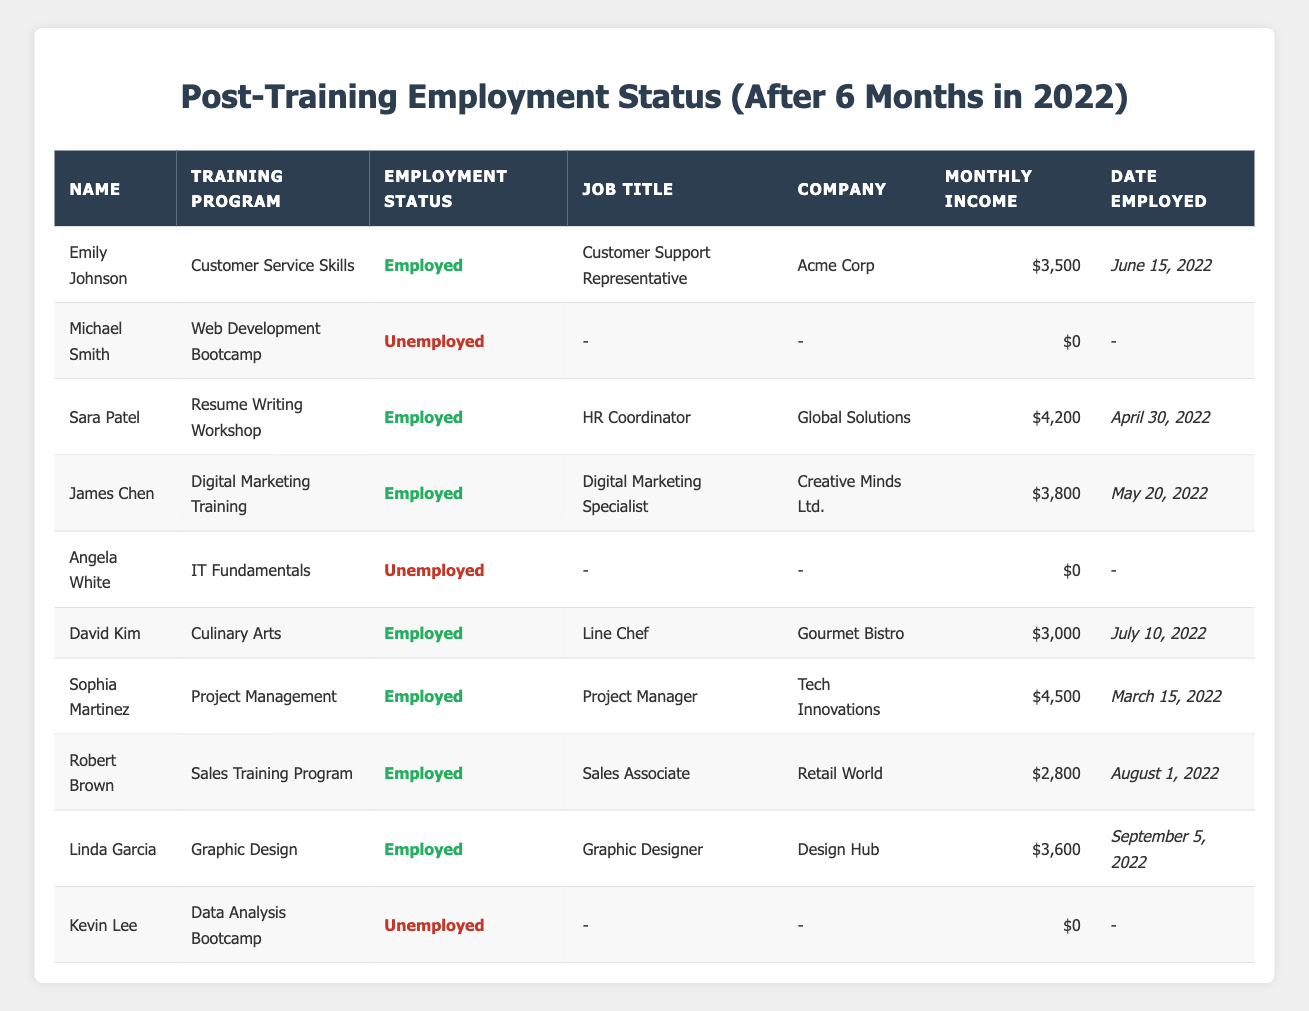What is the job title of Emily Johnson? According to the table, Emily Johnson holds the job title of "Customer Support Representative" under the "Employment Status" section.
Answer: Customer Support Representative How many participants are unemployed after the training? The table shows three entries (Michael Smith, Angela White, and Kevin Lee) with the "Employment Status" marked as "Unemployed." Thus, there are three unemployed participants.
Answer: 3 What is the total monthly income of all employed participants? Adding the monthly incomes of all employed participants: $3,500 (Emily) + $4,200 (Sara) + $3,800 (James) + $3,000 (David) + $4,500 (Sophia) + $2,800 (Robert) + $3,600 (Linda) = $25,400.
Answer: $25,400 Which training program had the highest earning participant? The participant with the highest monthly income is Sophia Martinez from the "Project Management" training program, earning $4,500 per month.
Answer: Project Management Is there more than one participant with the same job title? Checking the table, there are no duplicates in job titles: each participant has a unique title. Therefore, the answer is no.
Answer: No What was the average monthly income of employed participants? Calculating the average: Total income of employed participants is $25,400. There are 7 employed participants. Average = $25,400 / 7 = $3,628.57.
Answer: $3,628.57 Which participant had the earliest employment date? The earliest date in the "Date Employed" column is for Sophia Martinez, who was employed on "March 15, 2022."
Answer: Sophia Martinez How many participants were in training programs related to IT or technology fields? The relevant training programs are "Web Development Bootcamp," "IT Fundamentals," and "Data Analysis Bootcamp," which include Michael Smith, Angela White, and Kevin Lee. Thus, there are three participants.
Answer: 3 What is the difference in monthly income between the highest and lowest earning participants? The highest earning participant is Sophia Martinez with $4,500, and the lowest is Robert Brown with $2,800. The difference is $4,500 - $2,800 = $1,700.
Answer: $1,700 Are all participants from the training programs employed after six months? By checking the "Employment Status" column, it is apparent that four participants (Michael, Angela, and Kevin) are unemployed. Thus, not all participants are employed.
Answer: No 